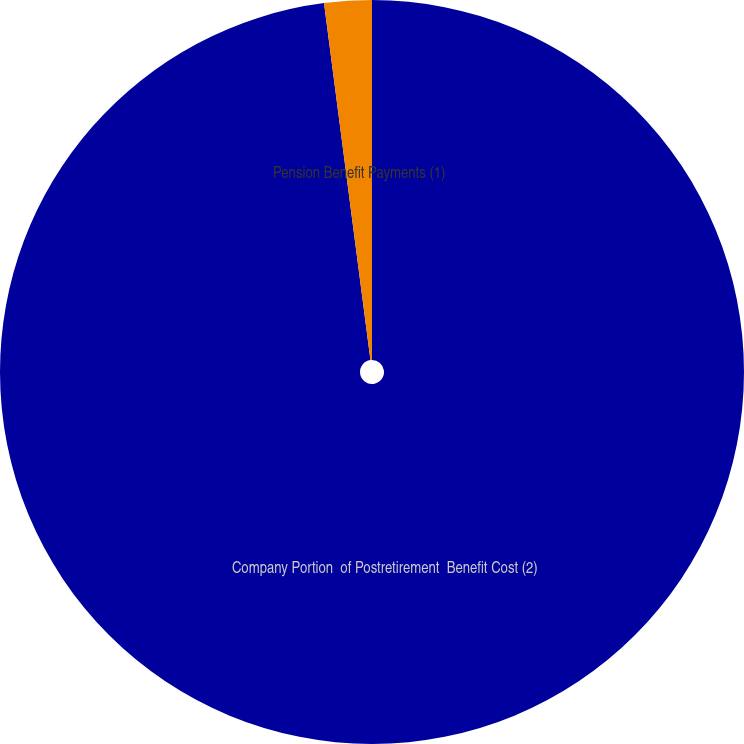<chart> <loc_0><loc_0><loc_500><loc_500><pie_chart><fcel>Company Portion  of Postretirement  Benefit Cost (2)<fcel>Pension Benefit Payments (1)<nl><fcel>97.94%<fcel>2.06%<nl></chart> 